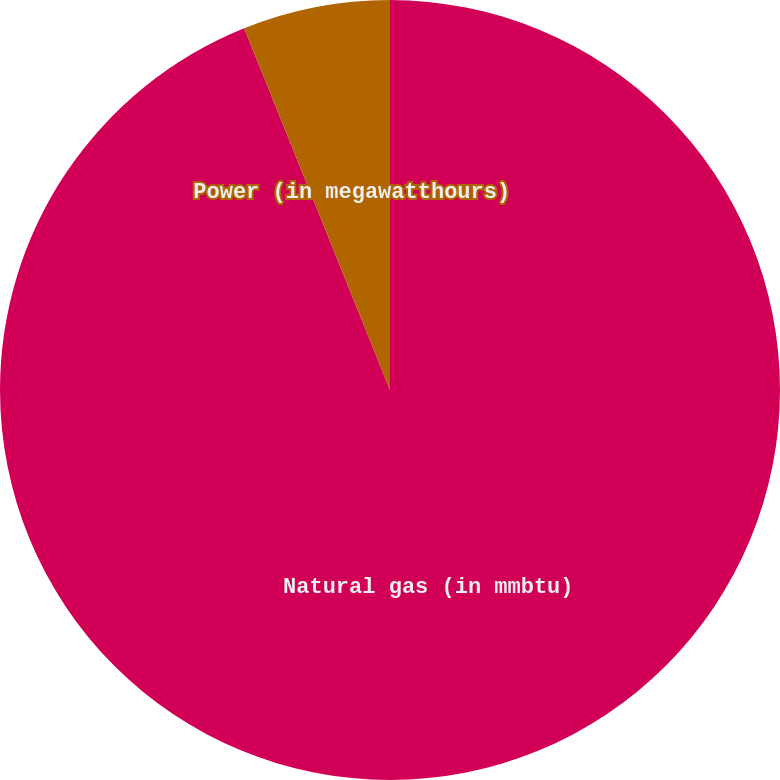Convert chart to OTSL. <chart><loc_0><loc_0><loc_500><loc_500><pie_chart><fcel>Natural gas (in mmbtu)<fcel>Power (in megawatthours)<nl><fcel>93.9%<fcel>6.1%<nl></chart> 